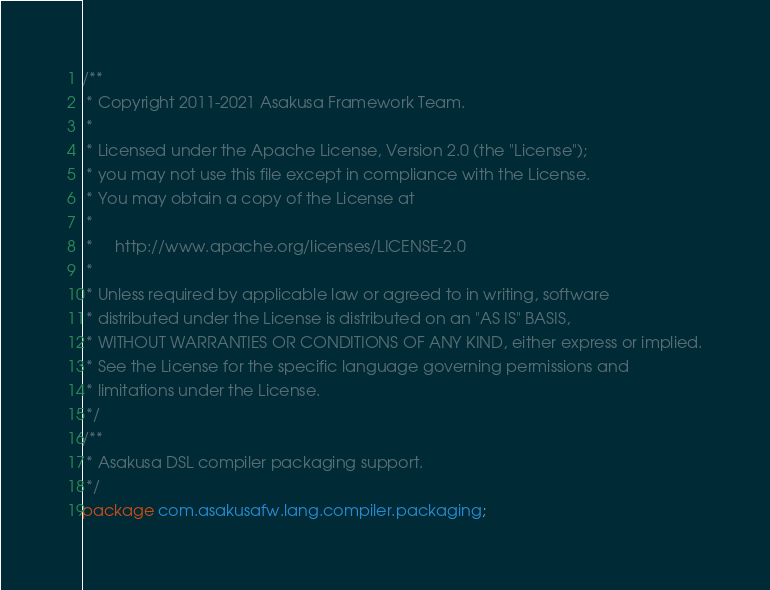<code> <loc_0><loc_0><loc_500><loc_500><_Java_>/**
 * Copyright 2011-2021 Asakusa Framework Team.
 *
 * Licensed under the Apache License, Version 2.0 (the "License");
 * you may not use this file except in compliance with the License.
 * You may obtain a copy of the License at
 *
 *     http://www.apache.org/licenses/LICENSE-2.0
 *
 * Unless required by applicable law or agreed to in writing, software
 * distributed under the License is distributed on an "AS IS" BASIS,
 * WITHOUT WARRANTIES OR CONDITIONS OF ANY KIND, either express or implied.
 * See the License for the specific language governing permissions and
 * limitations under the License.
 */
/**
 * Asakusa DSL compiler packaging support.
 */
package com.asakusafw.lang.compiler.packaging;</code> 